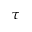<formula> <loc_0><loc_0><loc_500><loc_500>\tau</formula> 